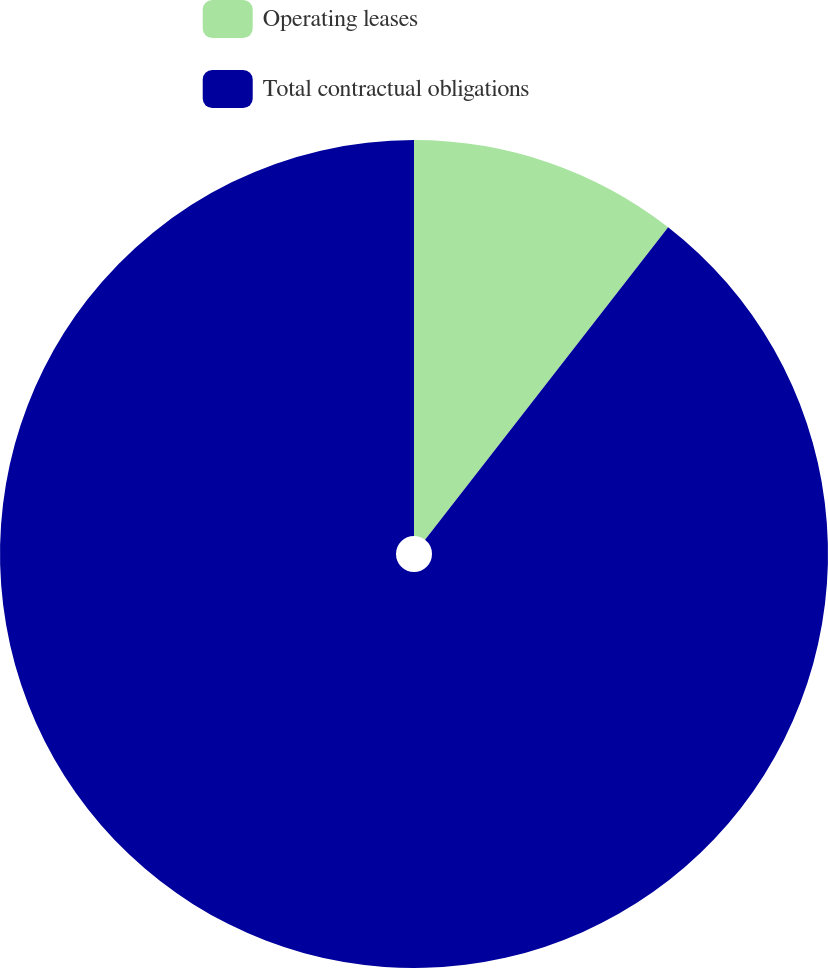<chart> <loc_0><loc_0><loc_500><loc_500><pie_chart><fcel>Operating leases<fcel>Total contractual obligations<nl><fcel>10.52%<fcel>89.48%<nl></chart> 